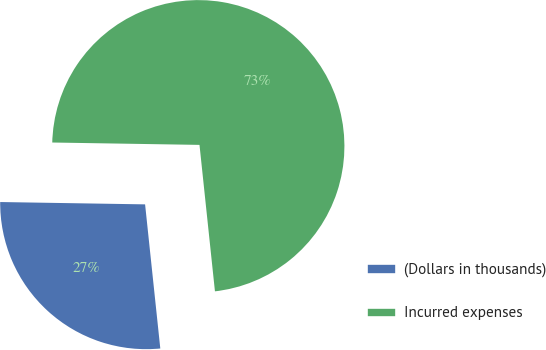<chart> <loc_0><loc_0><loc_500><loc_500><pie_chart><fcel>(Dollars in thousands)<fcel>Incurred expenses<nl><fcel>26.93%<fcel>73.07%<nl></chart> 